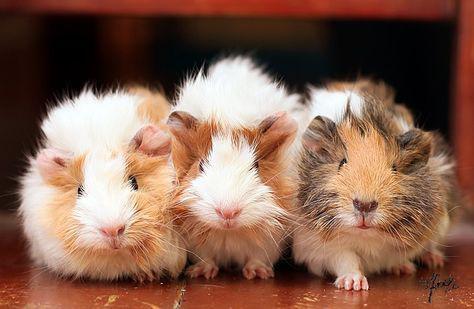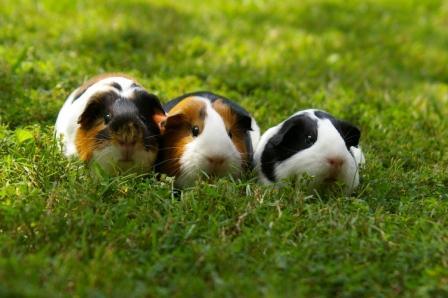The first image is the image on the left, the second image is the image on the right. For the images displayed, is the sentence "The left image contains a row of three guinea pigs, and the right image contains two guinea pigs with wavy fur." factually correct? Answer yes or no. No. The first image is the image on the left, the second image is the image on the right. Considering the images on both sides, is "The right image contains exactly two rodents." valid? Answer yes or no. No. 